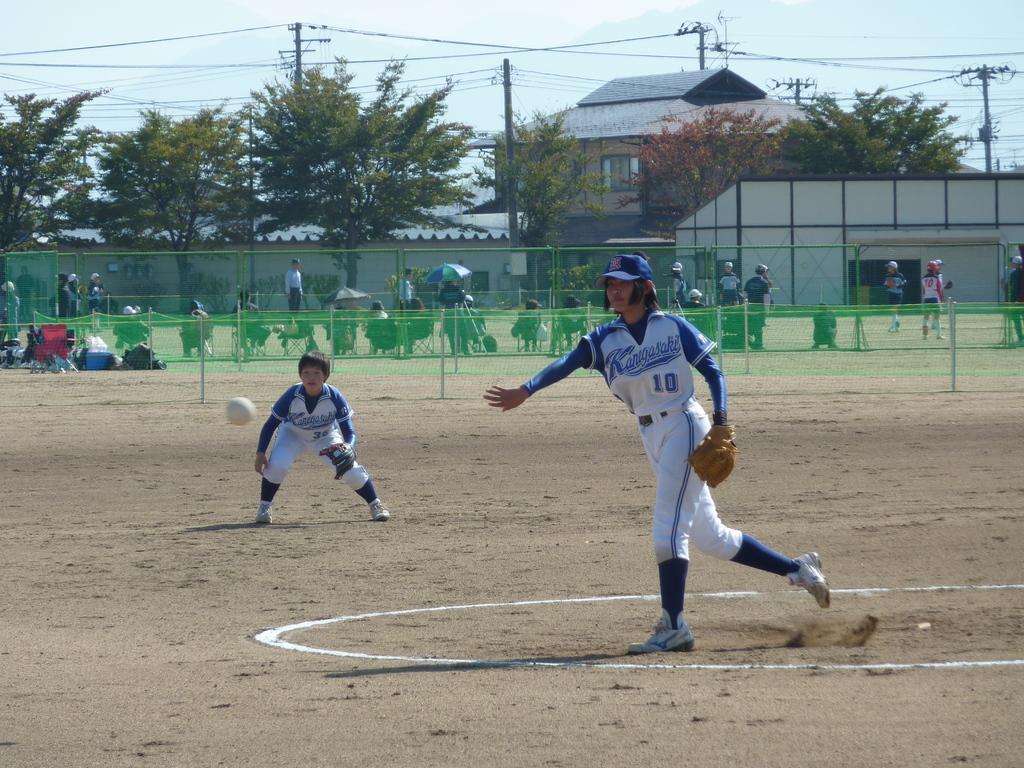Could you give a brief overview of what you see in this image? This picture shows few people standing and few are seated and we see couple of them playing baseball and we see gloves to their hands and we see trees and a building and few electrical poles and a cloudy sky and we see a metal fence. 